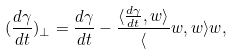Convert formula to latex. <formula><loc_0><loc_0><loc_500><loc_500>( \frac { d \gamma } { d t } ) _ { \perp } = \frac { d \gamma } { d t } - \frac { \langle \frac { d \gamma } { d t } , w \rangle } \langle w , w \rangle w ,</formula> 